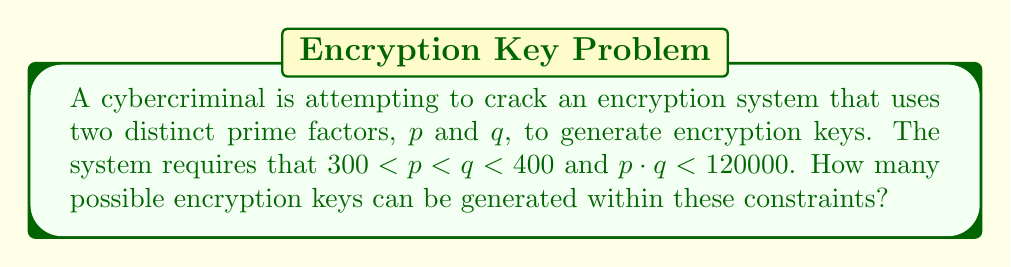Help me with this question. To solve this problem, we need to follow these steps:

1) First, list all the prime numbers between 300 and 400:
   $$ 307, 311, 313, 317, 331, 337, 347, 349, 353, 359, 367, 373, 379, 383, 389, 397 $$

2) For each prime $p$, we need to find how many primes $q$ satisfy both conditions:
   $p < q < 400$ and $p \cdot q < 120000$

3) Let's go through each $p$:

   For $p = 307$:
   $q < 120000/307 \approx 390.88$
   So, all primes from 311 to 389 are valid (14 primes)

   For $p = 311$:
   $q < 120000/311 \approx 385.85$
   Primes from 313 to 383 are valid (13 primes)

   For $p = 313$:
   $q < 120000/313 \approx 383.39$
   Primes from 317 to 383 are valid (12 primes)

   For $p = 317$:
   $q < 120000/317 \approx 378.55$
   Primes from 331 to 373 are valid (9 primes)

   For $p = 331$:
   $q < 120000/331 \approx 362.54$
   Primes from 337 to 359 are valid (5 primes)

   For $p = 337$:
   $q < 120000/337 \approx 355.99$
   Primes from 347 to 353 are valid (3 primes)

   For $p = 347$:
   $q < 120000/347 \approx 345.82$
   No valid $q$

4) For $p \geq 347$, there are no valid $q$.

5) Sum up all the valid pairs:
   $$ 14 + 13 + 12 + 9 + 5 + 3 = 56 $$

Therefore, there are 56 possible encryption keys that satisfy the given constraints.
Answer: 56 